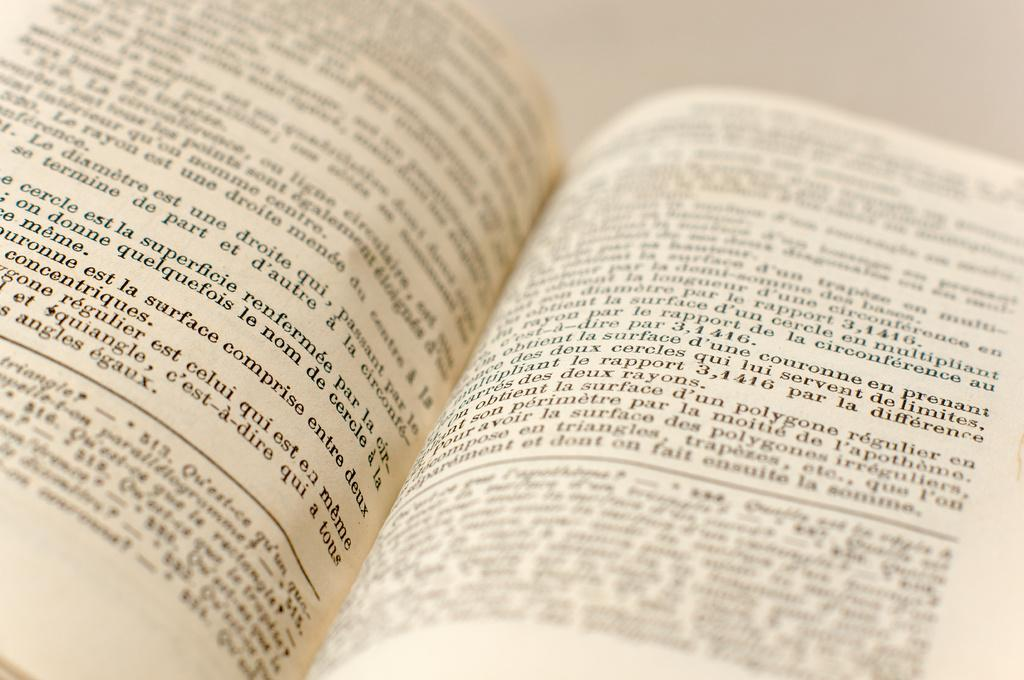<image>
Describe the image concisely. The open pages of a book displaying french text, there are footnotes that imply a nonfiction work. 